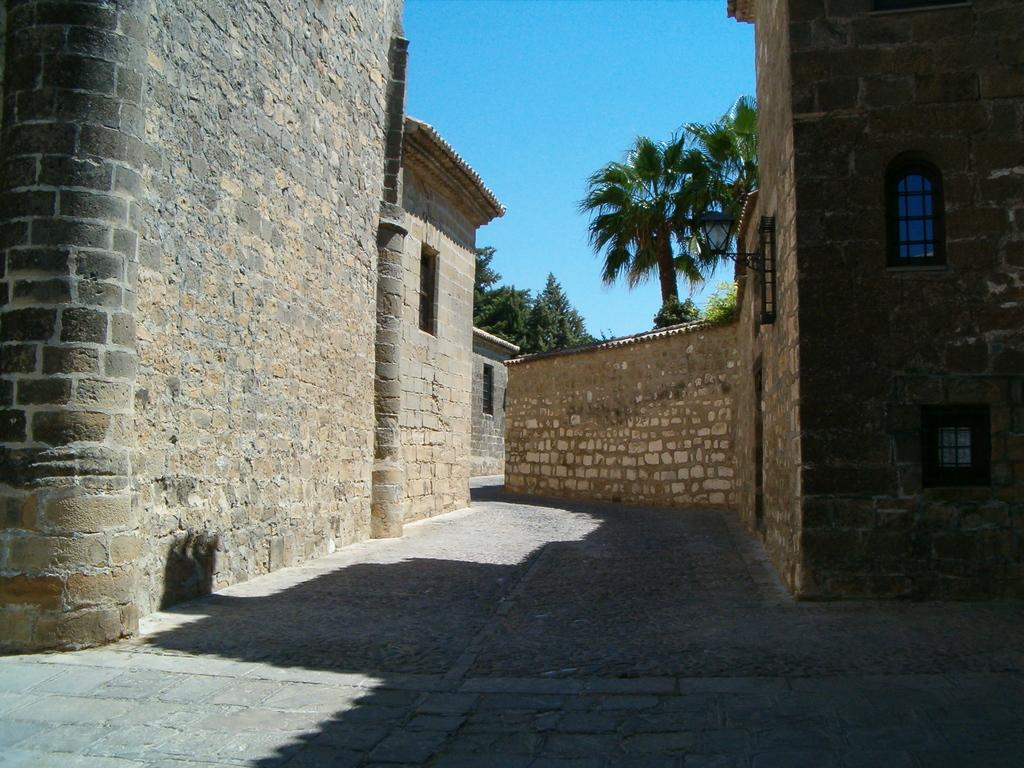What type of structures are visible in the image? There are walls with windows in the image. What type of vegetation can be seen in the image? There are trees visible in the image. What is visible in the background of the image? The sky is visible in the background of the image. What type of stamp can be seen on the trees in the image? There are no stamps visible on the trees in the image; only trees and the sky are present. What type of drum is being played in the background of the image? There is no drum present in the image; it only features walls with windows, trees, and the sky. 